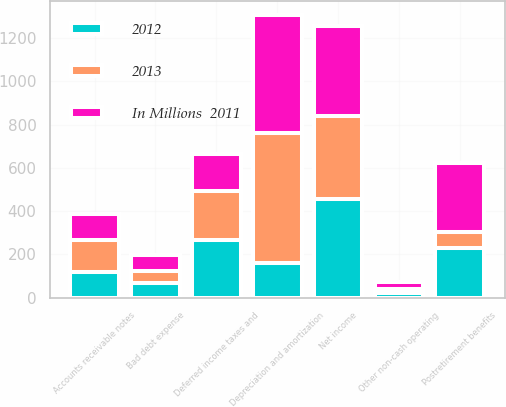Convert chart. <chart><loc_0><loc_0><loc_500><loc_500><stacked_bar_chart><ecel><fcel>Net income<fcel>Depreciation and amortization<fcel>Deferred income taxes and<fcel>Postretirement benefits<fcel>Bad debt expense<fcel>Other non-cash operating<fcel>Accounts receivable notes<nl><fcel>2012<fcel>454<fcel>161<fcel>268<fcel>229<fcel>67<fcel>22<fcel>120<nl><fcel>2013<fcel>384<fcel>598<fcel>227<fcel>72<fcel>57<fcel>16<fcel>147<nl><fcel>In Millions  2011<fcel>417<fcel>546<fcel>167<fcel>323<fcel>74<fcel>33<fcel>119<nl></chart> 